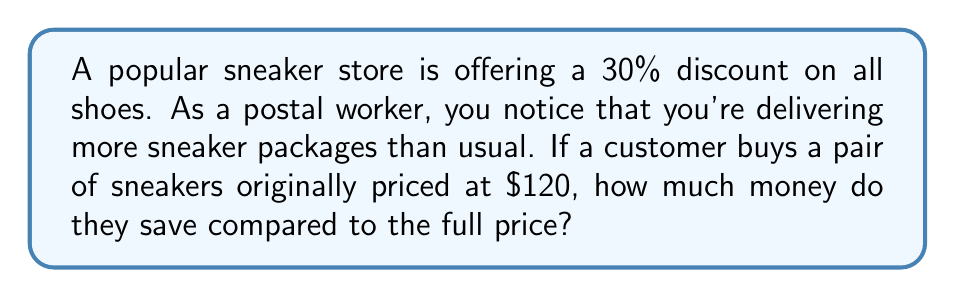What is the answer to this math problem? Let's solve this problem step by step:

1) First, we need to calculate the discount amount:
   The discount is 30% of the original price.
   $$\text{Discount} = 30\% \times \$120$$
   $$\text{Discount} = 0.30 \times \$120 = \$36$$

2) The amount saved is equal to the discount amount:
   $$\text{Savings} = \$36$$

Therefore, the customer saves $36 compared to the full price.
Answer: $36 